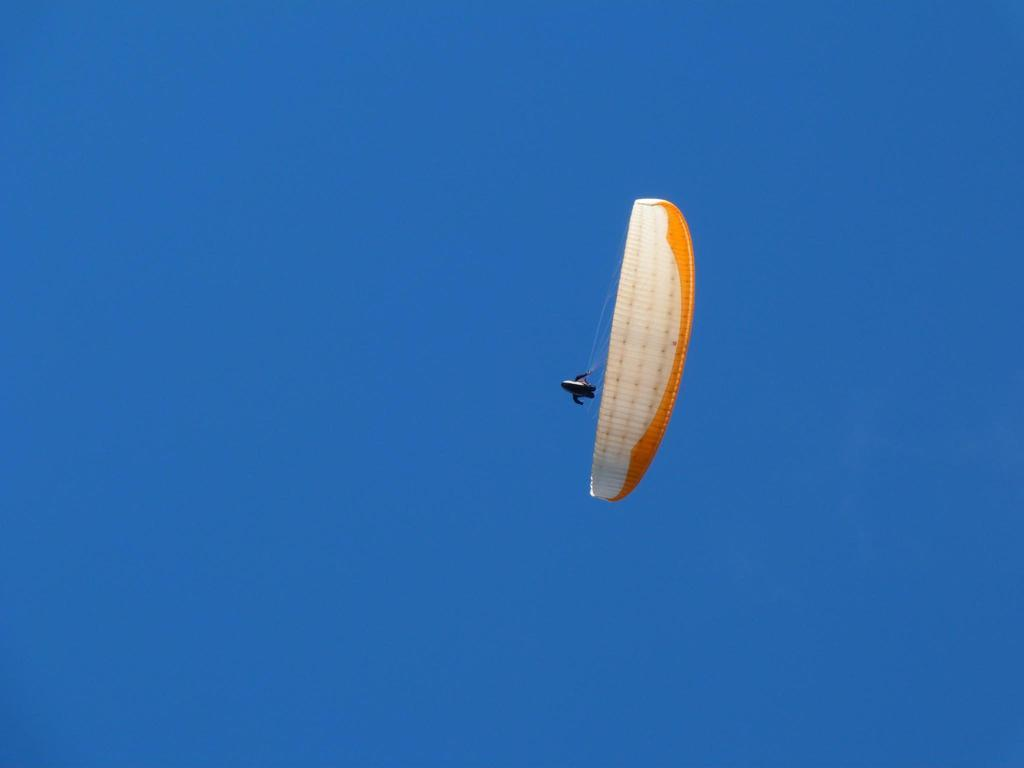What is the main object in the image? There is a parachute in the image. Where is the parachute located? The parachute is flying in the sky. What type of advertisement is attached to the tail of the parachute in the image? There is no tail or advertisement present on the parachute in the image. How does the parachute handle the rainstorm in the image? There is no rainstorm present in the image; the parachute is simply flying in the sky. 